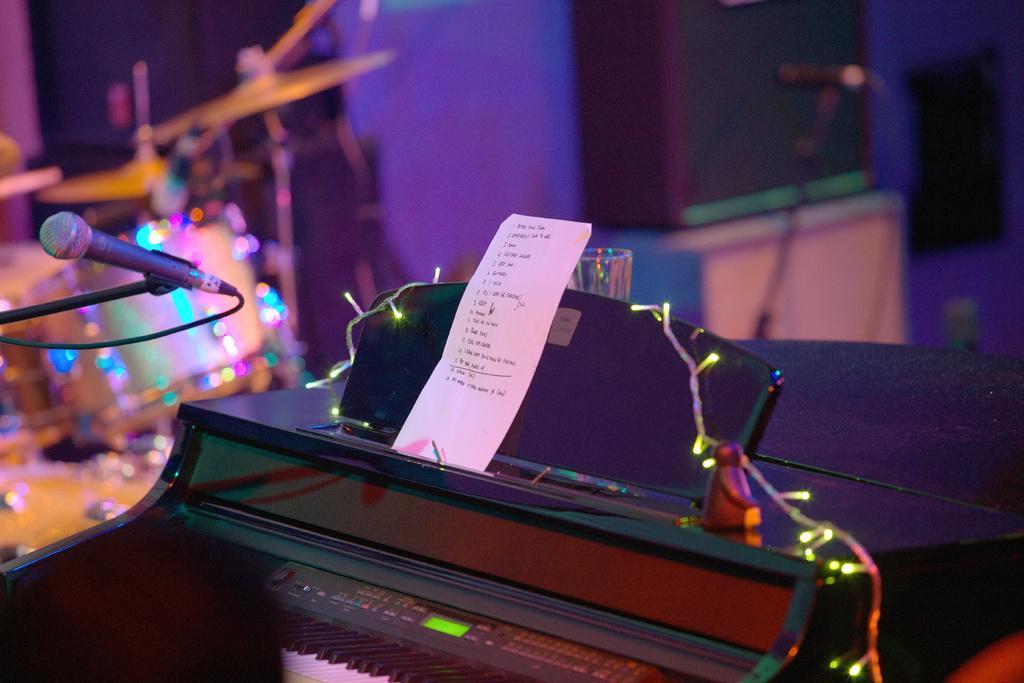In one or two sentences, can you explain what this image depicts? In the image there is a piano with a paper and mic above it with lights on it and in the back there is a drum kit. 